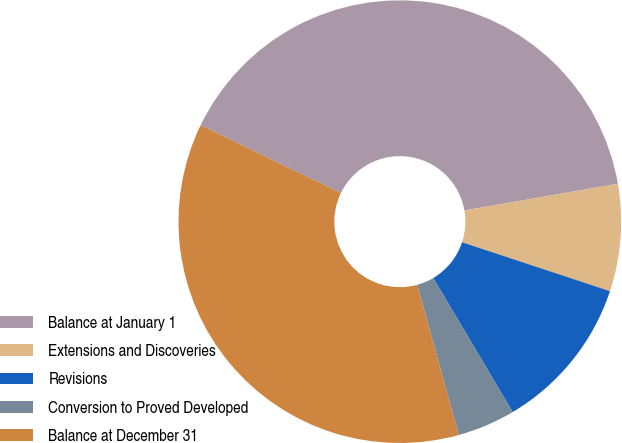Convert chart. <chart><loc_0><loc_0><loc_500><loc_500><pie_chart><fcel>Balance at January 1<fcel>Extensions and Discoveries<fcel>Revisions<fcel>Conversion to Proved Developed<fcel>Balance at December 31<nl><fcel>40.08%<fcel>7.82%<fcel>11.4%<fcel>4.23%<fcel>36.47%<nl></chart> 